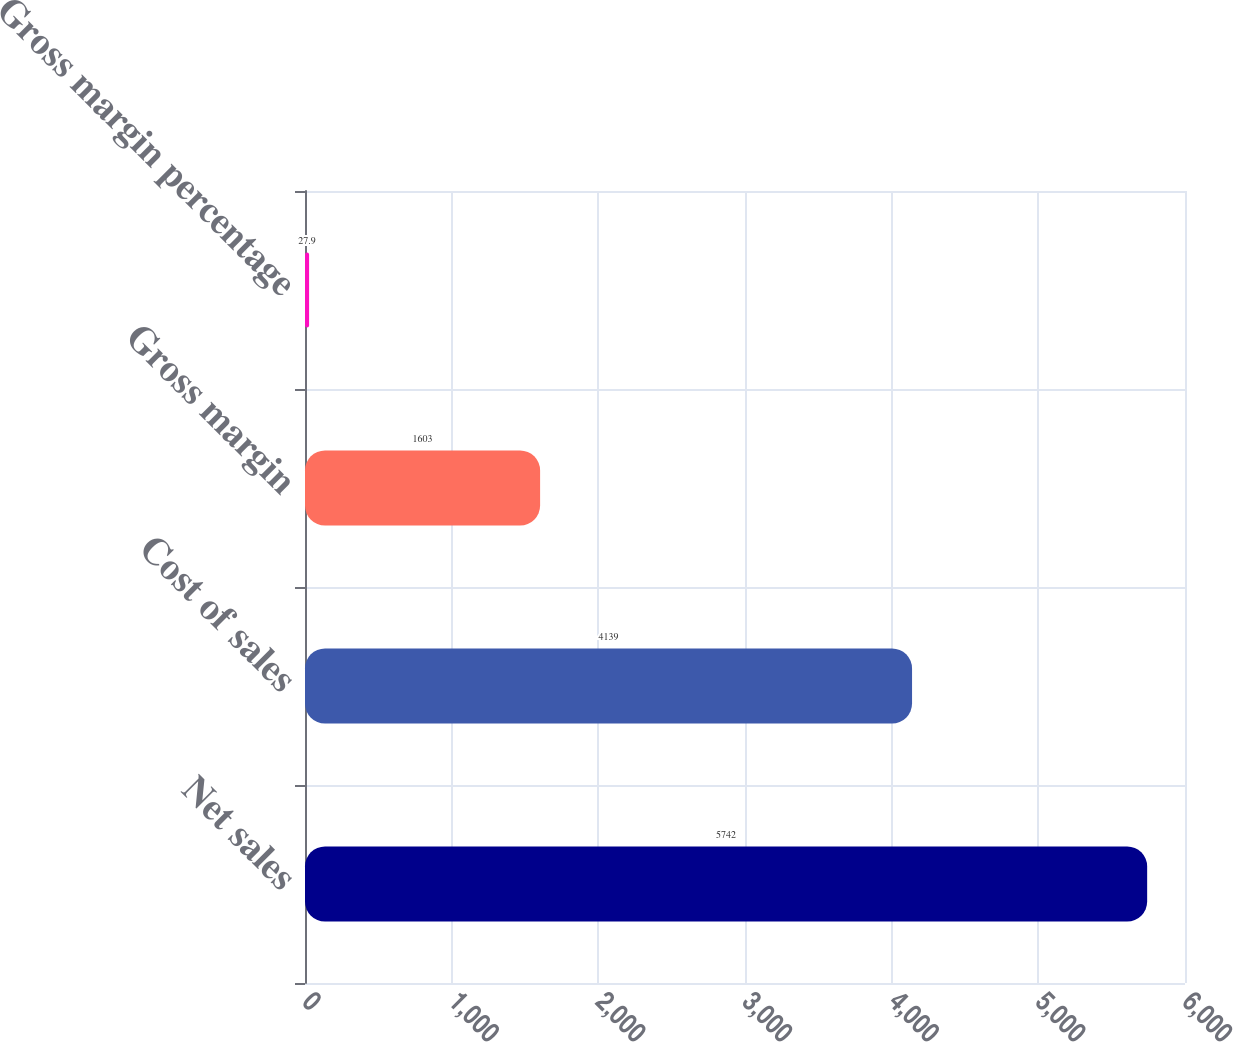Convert chart to OTSL. <chart><loc_0><loc_0><loc_500><loc_500><bar_chart><fcel>Net sales<fcel>Cost of sales<fcel>Gross margin<fcel>Gross margin percentage<nl><fcel>5742<fcel>4139<fcel>1603<fcel>27.9<nl></chart> 